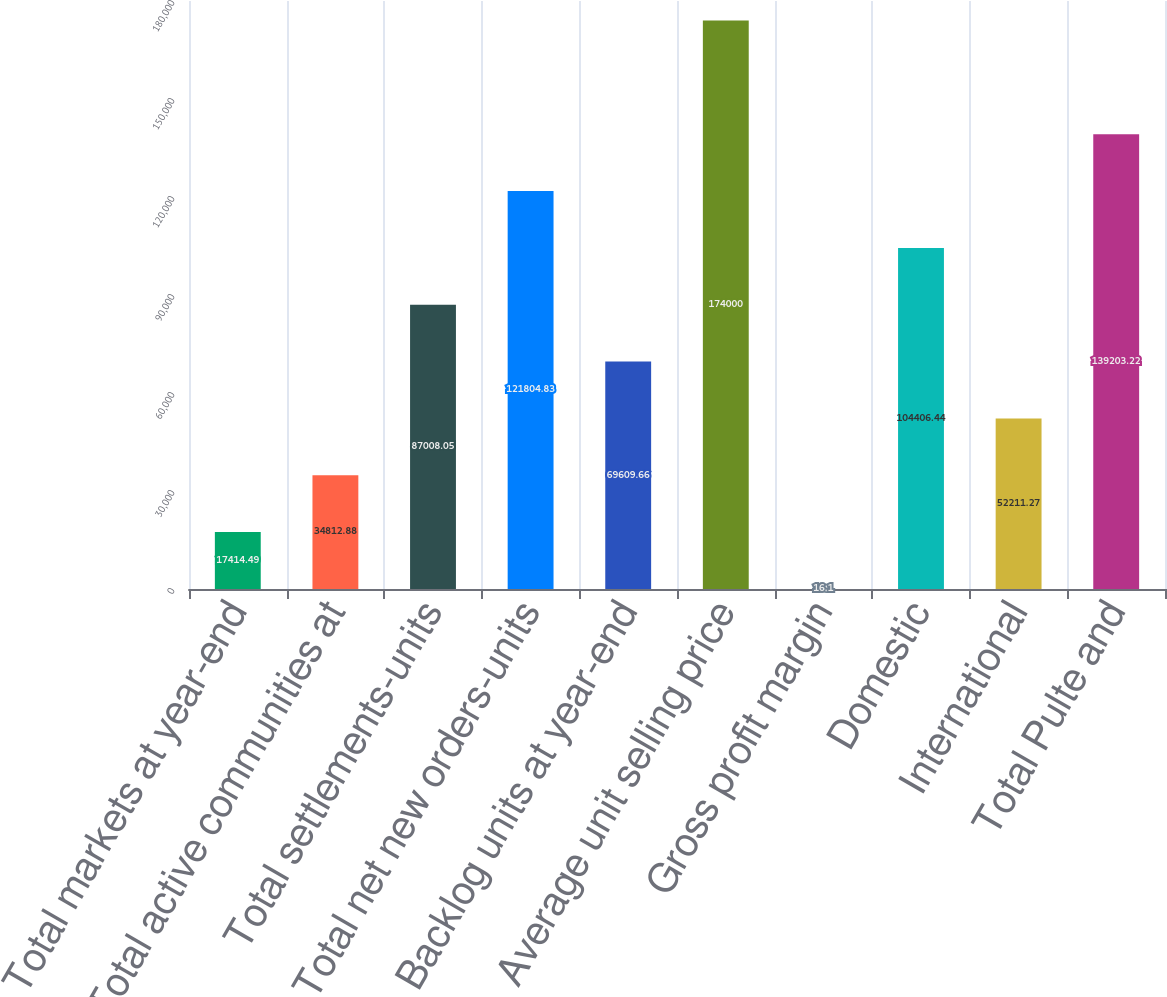Convert chart. <chart><loc_0><loc_0><loc_500><loc_500><bar_chart><fcel>Total markets at year-end<fcel>Total active communities at<fcel>Total settlements-units<fcel>Total net new orders-units<fcel>Backlog units at year-end<fcel>Average unit selling price<fcel>Gross profit margin<fcel>Domestic<fcel>International<fcel>Total Pulte and<nl><fcel>17414.5<fcel>34812.9<fcel>87008.1<fcel>121805<fcel>69609.7<fcel>174000<fcel>16.1<fcel>104406<fcel>52211.3<fcel>139203<nl></chart> 